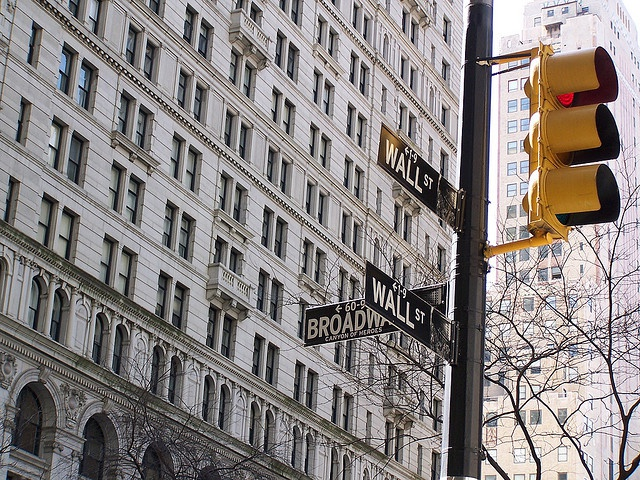Describe the objects in this image and their specific colors. I can see a traffic light in gray, olive, black, white, and maroon tones in this image. 